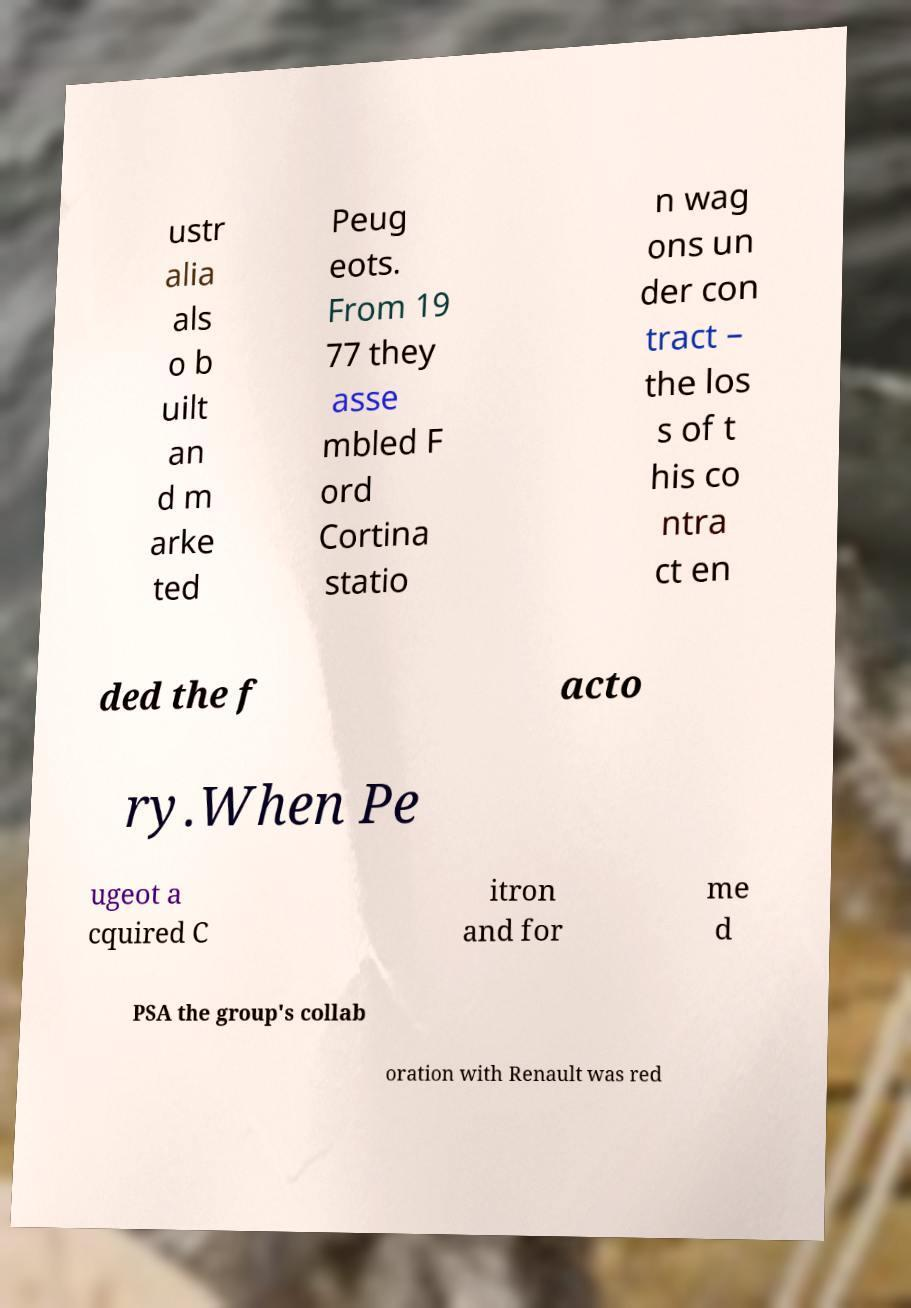Can you accurately transcribe the text from the provided image for me? ustr alia als o b uilt an d m arke ted Peug eots. From 19 77 they asse mbled F ord Cortina statio n wag ons un der con tract – the los s of t his co ntra ct en ded the f acto ry.When Pe ugeot a cquired C itron and for me d PSA the group's collab oration with Renault was red 